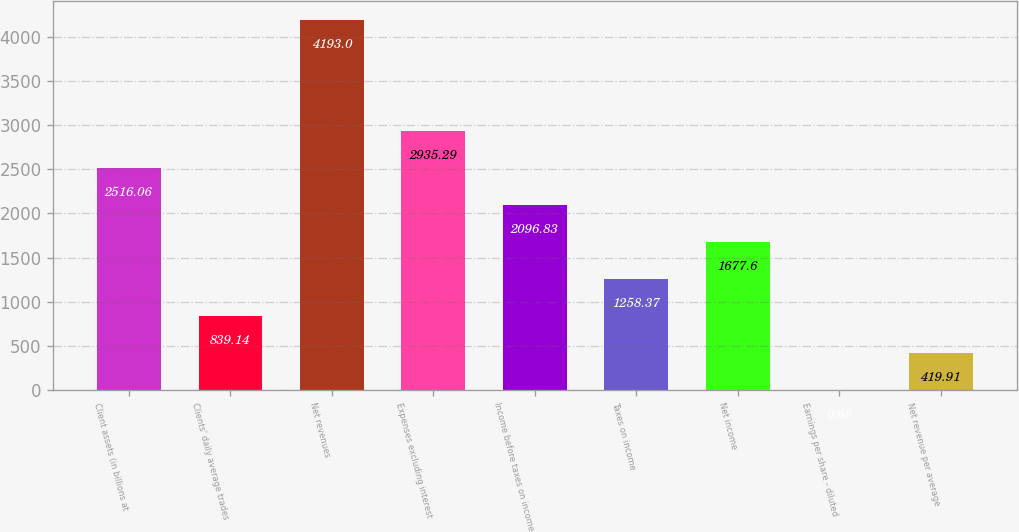<chart> <loc_0><loc_0><loc_500><loc_500><bar_chart><fcel>Client assets (in billions at<fcel>Clients' daily average trades<fcel>Net revenues<fcel>Expenses excluding interest<fcel>Income before taxes on income<fcel>Taxes on income<fcel>Net income<fcel>Earnings per share - diluted<fcel>Net revenue per average<nl><fcel>2516.06<fcel>839.14<fcel>4193<fcel>2935.29<fcel>2096.83<fcel>1258.37<fcel>1677.6<fcel>0.68<fcel>419.91<nl></chart> 